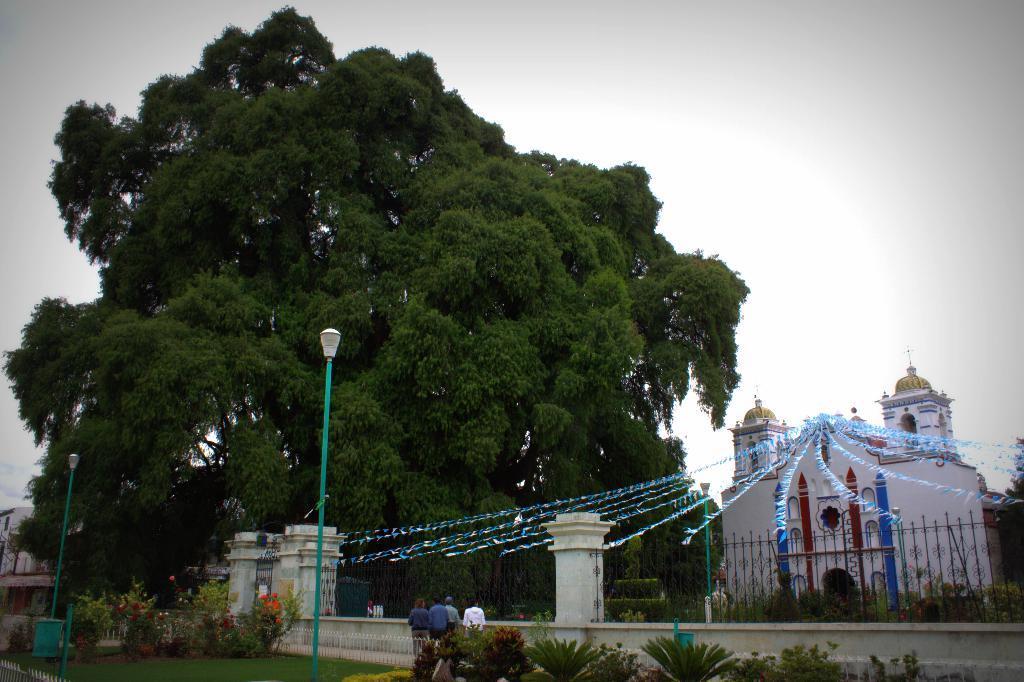Please provide a concise description of this image. At the bottom we can see planets,light poles,few persons are standing at the wall. In the background there are trees,fence,plants,buildings,flags tied to the ropes and clouds in the sky. 